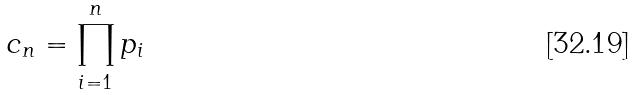<formula> <loc_0><loc_0><loc_500><loc_500>c _ { n } = \prod _ { i = 1 } ^ { n } p _ { i }</formula> 